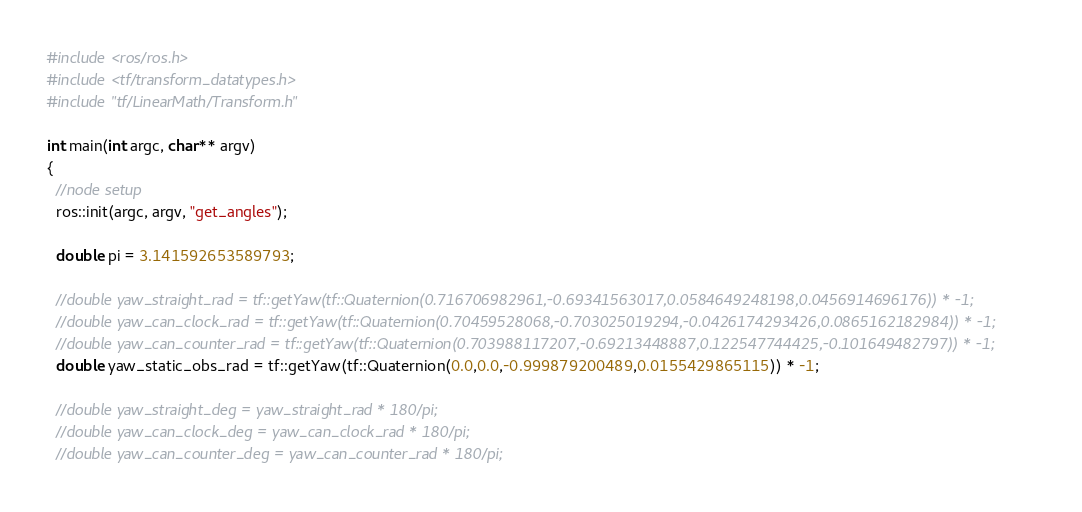<code> <loc_0><loc_0><loc_500><loc_500><_C++_>#include <ros/ros.h>
#include <tf/transform_datatypes.h>
#include "tf/LinearMath/Transform.h"

int main(int argc, char** argv)
{
  //node setup
  ros::init(argc, argv, "get_angles");

  double pi = 3.141592653589793;

  //double yaw_straight_rad = tf::getYaw(tf::Quaternion(0.716706982961,-0.69341563017,0.0584649248198,0.0456914696176)) * -1;
  //double yaw_can_clock_rad = tf::getYaw(tf::Quaternion(0.70459528068,-0.703025019294,-0.0426174293426,0.0865162182984)) * -1;
  //double yaw_can_counter_rad = tf::getYaw(tf::Quaternion(0.703988117207,-0.69213448887,0.122547744425,-0.101649482797)) * -1;
  double yaw_static_obs_rad = tf::getYaw(tf::Quaternion(0.0,0.0,-0.999879200489,0.0155429865115)) * -1;

  //double yaw_straight_deg = yaw_straight_rad * 180/pi;
  //double yaw_can_clock_deg = yaw_can_clock_rad * 180/pi;
  //double yaw_can_counter_deg = yaw_can_counter_rad * 180/pi;
</code> 